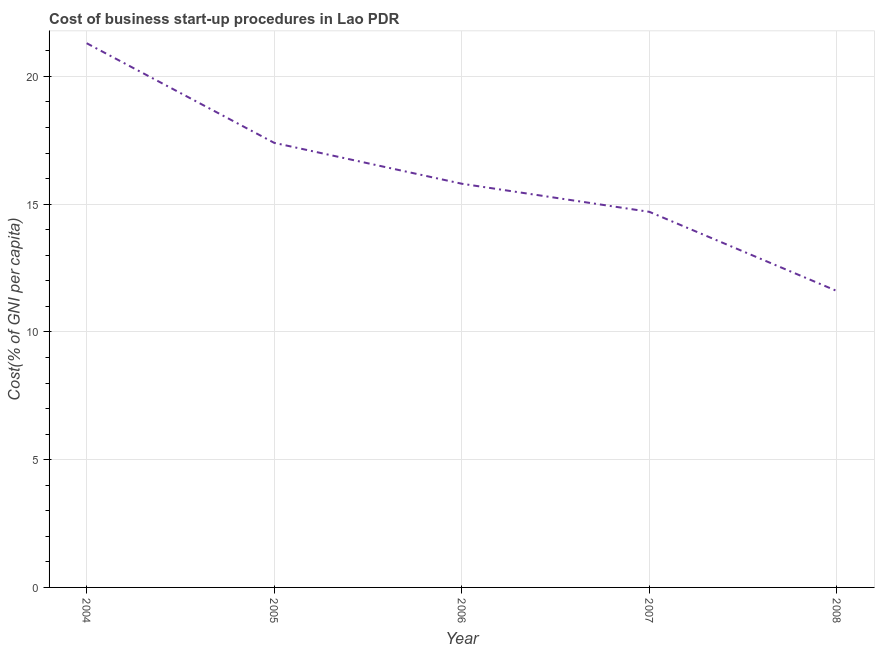What is the cost of business startup procedures in 2005?
Your response must be concise. 17.4. Across all years, what is the maximum cost of business startup procedures?
Offer a very short reply. 21.3. Across all years, what is the minimum cost of business startup procedures?
Offer a very short reply. 11.6. In which year was the cost of business startup procedures maximum?
Keep it short and to the point. 2004. What is the sum of the cost of business startup procedures?
Provide a succinct answer. 80.8. What is the difference between the cost of business startup procedures in 2005 and 2008?
Give a very brief answer. 5.8. What is the average cost of business startup procedures per year?
Provide a succinct answer. 16.16. In how many years, is the cost of business startup procedures greater than 2 %?
Keep it short and to the point. 5. Do a majority of the years between 2004 and 2008 (inclusive) have cost of business startup procedures greater than 2 %?
Your answer should be compact. Yes. What is the ratio of the cost of business startup procedures in 2007 to that in 2008?
Give a very brief answer. 1.27. Is the difference between the cost of business startup procedures in 2004 and 2006 greater than the difference between any two years?
Your answer should be very brief. No. What is the difference between the highest and the second highest cost of business startup procedures?
Provide a short and direct response. 3.9. Is the sum of the cost of business startup procedures in 2004 and 2005 greater than the maximum cost of business startup procedures across all years?
Keep it short and to the point. Yes. What is the difference between the highest and the lowest cost of business startup procedures?
Your answer should be compact. 9.7. In how many years, is the cost of business startup procedures greater than the average cost of business startup procedures taken over all years?
Ensure brevity in your answer.  2. Does the cost of business startup procedures monotonically increase over the years?
Give a very brief answer. No. How many years are there in the graph?
Provide a succinct answer. 5. Does the graph contain any zero values?
Ensure brevity in your answer.  No. What is the title of the graph?
Make the answer very short. Cost of business start-up procedures in Lao PDR. What is the label or title of the Y-axis?
Provide a succinct answer. Cost(% of GNI per capita). What is the Cost(% of GNI per capita) in 2004?
Provide a succinct answer. 21.3. What is the difference between the Cost(% of GNI per capita) in 2004 and 2006?
Offer a terse response. 5.5. What is the difference between the Cost(% of GNI per capita) in 2004 and 2008?
Provide a succinct answer. 9.7. What is the difference between the Cost(% of GNI per capita) in 2005 and 2006?
Offer a very short reply. 1.6. What is the difference between the Cost(% of GNI per capita) in 2005 and 2008?
Offer a very short reply. 5.8. What is the difference between the Cost(% of GNI per capita) in 2006 and 2008?
Offer a very short reply. 4.2. What is the difference between the Cost(% of GNI per capita) in 2007 and 2008?
Ensure brevity in your answer.  3.1. What is the ratio of the Cost(% of GNI per capita) in 2004 to that in 2005?
Provide a short and direct response. 1.22. What is the ratio of the Cost(% of GNI per capita) in 2004 to that in 2006?
Your response must be concise. 1.35. What is the ratio of the Cost(% of GNI per capita) in 2004 to that in 2007?
Provide a short and direct response. 1.45. What is the ratio of the Cost(% of GNI per capita) in 2004 to that in 2008?
Make the answer very short. 1.84. What is the ratio of the Cost(% of GNI per capita) in 2005 to that in 2006?
Your answer should be very brief. 1.1. What is the ratio of the Cost(% of GNI per capita) in 2005 to that in 2007?
Ensure brevity in your answer.  1.18. What is the ratio of the Cost(% of GNI per capita) in 2005 to that in 2008?
Your answer should be compact. 1.5. What is the ratio of the Cost(% of GNI per capita) in 2006 to that in 2007?
Give a very brief answer. 1.07. What is the ratio of the Cost(% of GNI per capita) in 2006 to that in 2008?
Offer a very short reply. 1.36. What is the ratio of the Cost(% of GNI per capita) in 2007 to that in 2008?
Your answer should be compact. 1.27. 